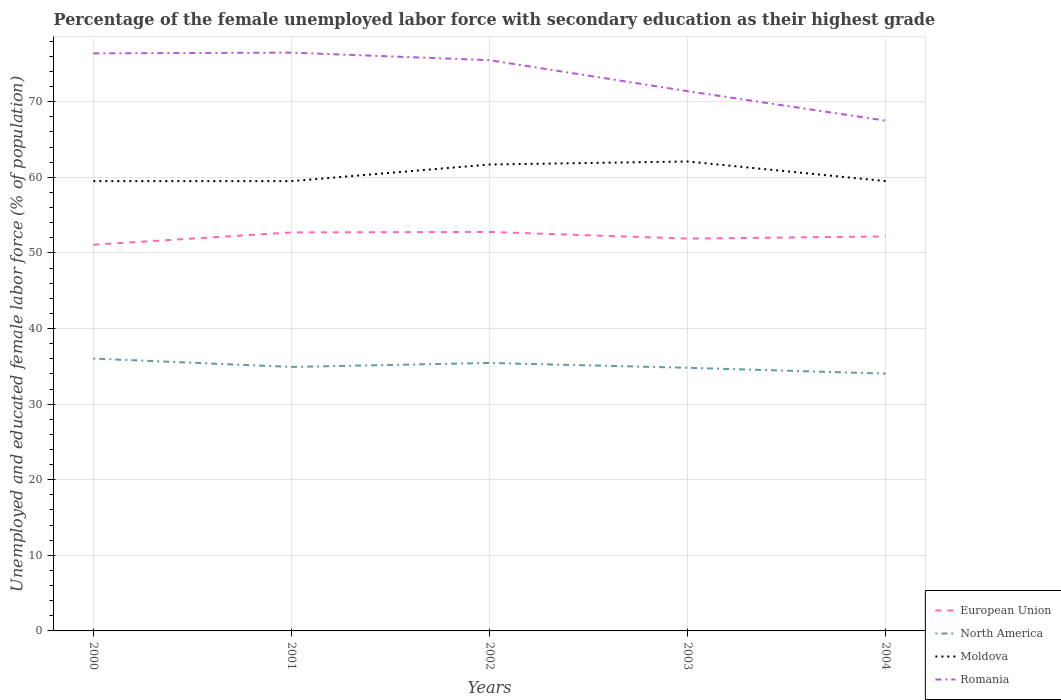Does the line corresponding to North America intersect with the line corresponding to European Union?
Your answer should be compact. No. Across all years, what is the maximum percentage of the unemployed female labor force with secondary education in Romania?
Your answer should be compact. 67.5. In which year was the percentage of the unemployed female labor force with secondary education in Moldova maximum?
Offer a terse response. 2000. What is the total percentage of the unemployed female labor force with secondary education in Romania in the graph?
Your answer should be compact. 5. What is the difference between the highest and the lowest percentage of the unemployed female labor force with secondary education in Moldova?
Offer a very short reply. 2. Does the graph contain any zero values?
Ensure brevity in your answer.  No. Does the graph contain grids?
Make the answer very short. Yes. How many legend labels are there?
Give a very brief answer. 4. How are the legend labels stacked?
Make the answer very short. Vertical. What is the title of the graph?
Offer a terse response. Percentage of the female unemployed labor force with secondary education as their highest grade. What is the label or title of the Y-axis?
Ensure brevity in your answer.  Unemployed and educated female labor force (% of population). What is the Unemployed and educated female labor force (% of population) of European Union in 2000?
Give a very brief answer. 51.09. What is the Unemployed and educated female labor force (% of population) of North America in 2000?
Offer a terse response. 36.03. What is the Unemployed and educated female labor force (% of population) in Moldova in 2000?
Your answer should be compact. 59.5. What is the Unemployed and educated female labor force (% of population) in Romania in 2000?
Your response must be concise. 76.4. What is the Unemployed and educated female labor force (% of population) in European Union in 2001?
Your response must be concise. 52.72. What is the Unemployed and educated female labor force (% of population) in North America in 2001?
Provide a short and direct response. 34.92. What is the Unemployed and educated female labor force (% of population) of Moldova in 2001?
Your answer should be very brief. 59.5. What is the Unemployed and educated female labor force (% of population) in Romania in 2001?
Your answer should be very brief. 76.5. What is the Unemployed and educated female labor force (% of population) in European Union in 2002?
Provide a short and direct response. 52.78. What is the Unemployed and educated female labor force (% of population) of North America in 2002?
Give a very brief answer. 35.45. What is the Unemployed and educated female labor force (% of population) of Moldova in 2002?
Make the answer very short. 61.7. What is the Unemployed and educated female labor force (% of population) of Romania in 2002?
Offer a very short reply. 75.5. What is the Unemployed and educated female labor force (% of population) in European Union in 2003?
Provide a short and direct response. 51.9. What is the Unemployed and educated female labor force (% of population) in North America in 2003?
Keep it short and to the point. 34.81. What is the Unemployed and educated female labor force (% of population) of Moldova in 2003?
Make the answer very short. 62.1. What is the Unemployed and educated female labor force (% of population) of Romania in 2003?
Give a very brief answer. 71.4. What is the Unemployed and educated female labor force (% of population) in European Union in 2004?
Give a very brief answer. 52.19. What is the Unemployed and educated female labor force (% of population) in North America in 2004?
Ensure brevity in your answer.  34.04. What is the Unemployed and educated female labor force (% of population) of Moldova in 2004?
Provide a succinct answer. 59.5. What is the Unemployed and educated female labor force (% of population) of Romania in 2004?
Keep it short and to the point. 67.5. Across all years, what is the maximum Unemployed and educated female labor force (% of population) in European Union?
Give a very brief answer. 52.78. Across all years, what is the maximum Unemployed and educated female labor force (% of population) of North America?
Keep it short and to the point. 36.03. Across all years, what is the maximum Unemployed and educated female labor force (% of population) of Moldova?
Provide a succinct answer. 62.1. Across all years, what is the maximum Unemployed and educated female labor force (% of population) of Romania?
Give a very brief answer. 76.5. Across all years, what is the minimum Unemployed and educated female labor force (% of population) in European Union?
Your answer should be compact. 51.09. Across all years, what is the minimum Unemployed and educated female labor force (% of population) of North America?
Give a very brief answer. 34.04. Across all years, what is the minimum Unemployed and educated female labor force (% of population) of Moldova?
Give a very brief answer. 59.5. Across all years, what is the minimum Unemployed and educated female labor force (% of population) in Romania?
Offer a terse response. 67.5. What is the total Unemployed and educated female labor force (% of population) of European Union in the graph?
Your answer should be compact. 260.67. What is the total Unemployed and educated female labor force (% of population) of North America in the graph?
Ensure brevity in your answer.  175.25. What is the total Unemployed and educated female labor force (% of population) in Moldova in the graph?
Your response must be concise. 302.3. What is the total Unemployed and educated female labor force (% of population) of Romania in the graph?
Offer a very short reply. 367.3. What is the difference between the Unemployed and educated female labor force (% of population) of European Union in 2000 and that in 2001?
Provide a short and direct response. -1.62. What is the difference between the Unemployed and educated female labor force (% of population) of North America in 2000 and that in 2001?
Ensure brevity in your answer.  1.11. What is the difference between the Unemployed and educated female labor force (% of population) in Moldova in 2000 and that in 2001?
Provide a short and direct response. 0. What is the difference between the Unemployed and educated female labor force (% of population) in European Union in 2000 and that in 2002?
Your answer should be very brief. -1.69. What is the difference between the Unemployed and educated female labor force (% of population) of North America in 2000 and that in 2002?
Keep it short and to the point. 0.58. What is the difference between the Unemployed and educated female labor force (% of population) of Romania in 2000 and that in 2002?
Provide a succinct answer. 0.9. What is the difference between the Unemployed and educated female labor force (% of population) of European Union in 2000 and that in 2003?
Provide a short and direct response. -0.81. What is the difference between the Unemployed and educated female labor force (% of population) in North America in 2000 and that in 2003?
Provide a succinct answer. 1.22. What is the difference between the Unemployed and educated female labor force (% of population) in European Union in 2000 and that in 2004?
Make the answer very short. -1.1. What is the difference between the Unemployed and educated female labor force (% of population) in North America in 2000 and that in 2004?
Make the answer very short. 1.99. What is the difference between the Unemployed and educated female labor force (% of population) in Moldova in 2000 and that in 2004?
Keep it short and to the point. 0. What is the difference between the Unemployed and educated female labor force (% of population) in Romania in 2000 and that in 2004?
Make the answer very short. 8.9. What is the difference between the Unemployed and educated female labor force (% of population) in European Union in 2001 and that in 2002?
Make the answer very short. -0.06. What is the difference between the Unemployed and educated female labor force (% of population) in North America in 2001 and that in 2002?
Give a very brief answer. -0.53. What is the difference between the Unemployed and educated female labor force (% of population) in Moldova in 2001 and that in 2002?
Make the answer very short. -2.2. What is the difference between the Unemployed and educated female labor force (% of population) of Romania in 2001 and that in 2002?
Ensure brevity in your answer.  1. What is the difference between the Unemployed and educated female labor force (% of population) in European Union in 2001 and that in 2003?
Provide a short and direct response. 0.82. What is the difference between the Unemployed and educated female labor force (% of population) in North America in 2001 and that in 2003?
Provide a short and direct response. 0.11. What is the difference between the Unemployed and educated female labor force (% of population) of Romania in 2001 and that in 2003?
Ensure brevity in your answer.  5.1. What is the difference between the Unemployed and educated female labor force (% of population) of European Union in 2001 and that in 2004?
Provide a short and direct response. 0.53. What is the difference between the Unemployed and educated female labor force (% of population) in North America in 2001 and that in 2004?
Provide a short and direct response. 0.88. What is the difference between the Unemployed and educated female labor force (% of population) in Moldova in 2001 and that in 2004?
Keep it short and to the point. 0. What is the difference between the Unemployed and educated female labor force (% of population) in European Union in 2002 and that in 2003?
Your answer should be compact. 0.88. What is the difference between the Unemployed and educated female labor force (% of population) of North America in 2002 and that in 2003?
Your answer should be very brief. 0.64. What is the difference between the Unemployed and educated female labor force (% of population) in Romania in 2002 and that in 2003?
Ensure brevity in your answer.  4.1. What is the difference between the Unemployed and educated female labor force (% of population) in European Union in 2002 and that in 2004?
Make the answer very short. 0.59. What is the difference between the Unemployed and educated female labor force (% of population) of North America in 2002 and that in 2004?
Your answer should be very brief. 1.41. What is the difference between the Unemployed and educated female labor force (% of population) in Romania in 2002 and that in 2004?
Your answer should be compact. 8. What is the difference between the Unemployed and educated female labor force (% of population) of European Union in 2003 and that in 2004?
Your answer should be very brief. -0.29. What is the difference between the Unemployed and educated female labor force (% of population) in North America in 2003 and that in 2004?
Provide a short and direct response. 0.77. What is the difference between the Unemployed and educated female labor force (% of population) in Moldova in 2003 and that in 2004?
Your response must be concise. 2.6. What is the difference between the Unemployed and educated female labor force (% of population) of European Union in 2000 and the Unemployed and educated female labor force (% of population) of North America in 2001?
Your answer should be very brief. 16.17. What is the difference between the Unemployed and educated female labor force (% of population) of European Union in 2000 and the Unemployed and educated female labor force (% of population) of Moldova in 2001?
Keep it short and to the point. -8.41. What is the difference between the Unemployed and educated female labor force (% of population) of European Union in 2000 and the Unemployed and educated female labor force (% of population) of Romania in 2001?
Make the answer very short. -25.41. What is the difference between the Unemployed and educated female labor force (% of population) of North America in 2000 and the Unemployed and educated female labor force (% of population) of Moldova in 2001?
Provide a succinct answer. -23.47. What is the difference between the Unemployed and educated female labor force (% of population) of North America in 2000 and the Unemployed and educated female labor force (% of population) of Romania in 2001?
Your answer should be very brief. -40.47. What is the difference between the Unemployed and educated female labor force (% of population) of Moldova in 2000 and the Unemployed and educated female labor force (% of population) of Romania in 2001?
Your response must be concise. -17. What is the difference between the Unemployed and educated female labor force (% of population) of European Union in 2000 and the Unemployed and educated female labor force (% of population) of North America in 2002?
Offer a terse response. 15.64. What is the difference between the Unemployed and educated female labor force (% of population) in European Union in 2000 and the Unemployed and educated female labor force (% of population) in Moldova in 2002?
Your answer should be compact. -10.61. What is the difference between the Unemployed and educated female labor force (% of population) of European Union in 2000 and the Unemployed and educated female labor force (% of population) of Romania in 2002?
Keep it short and to the point. -24.41. What is the difference between the Unemployed and educated female labor force (% of population) in North America in 2000 and the Unemployed and educated female labor force (% of population) in Moldova in 2002?
Your answer should be very brief. -25.67. What is the difference between the Unemployed and educated female labor force (% of population) of North America in 2000 and the Unemployed and educated female labor force (% of population) of Romania in 2002?
Your answer should be very brief. -39.47. What is the difference between the Unemployed and educated female labor force (% of population) of Moldova in 2000 and the Unemployed and educated female labor force (% of population) of Romania in 2002?
Keep it short and to the point. -16. What is the difference between the Unemployed and educated female labor force (% of population) in European Union in 2000 and the Unemployed and educated female labor force (% of population) in North America in 2003?
Provide a short and direct response. 16.28. What is the difference between the Unemployed and educated female labor force (% of population) in European Union in 2000 and the Unemployed and educated female labor force (% of population) in Moldova in 2003?
Your answer should be very brief. -11.01. What is the difference between the Unemployed and educated female labor force (% of population) in European Union in 2000 and the Unemployed and educated female labor force (% of population) in Romania in 2003?
Your response must be concise. -20.31. What is the difference between the Unemployed and educated female labor force (% of population) in North America in 2000 and the Unemployed and educated female labor force (% of population) in Moldova in 2003?
Your answer should be very brief. -26.07. What is the difference between the Unemployed and educated female labor force (% of population) of North America in 2000 and the Unemployed and educated female labor force (% of population) of Romania in 2003?
Keep it short and to the point. -35.37. What is the difference between the Unemployed and educated female labor force (% of population) in European Union in 2000 and the Unemployed and educated female labor force (% of population) in North America in 2004?
Your response must be concise. 17.05. What is the difference between the Unemployed and educated female labor force (% of population) of European Union in 2000 and the Unemployed and educated female labor force (% of population) of Moldova in 2004?
Keep it short and to the point. -8.41. What is the difference between the Unemployed and educated female labor force (% of population) of European Union in 2000 and the Unemployed and educated female labor force (% of population) of Romania in 2004?
Make the answer very short. -16.41. What is the difference between the Unemployed and educated female labor force (% of population) in North America in 2000 and the Unemployed and educated female labor force (% of population) in Moldova in 2004?
Your answer should be compact. -23.47. What is the difference between the Unemployed and educated female labor force (% of population) of North America in 2000 and the Unemployed and educated female labor force (% of population) of Romania in 2004?
Provide a short and direct response. -31.47. What is the difference between the Unemployed and educated female labor force (% of population) in European Union in 2001 and the Unemployed and educated female labor force (% of population) in North America in 2002?
Your response must be concise. 17.27. What is the difference between the Unemployed and educated female labor force (% of population) in European Union in 2001 and the Unemployed and educated female labor force (% of population) in Moldova in 2002?
Your answer should be compact. -8.98. What is the difference between the Unemployed and educated female labor force (% of population) in European Union in 2001 and the Unemployed and educated female labor force (% of population) in Romania in 2002?
Provide a succinct answer. -22.78. What is the difference between the Unemployed and educated female labor force (% of population) of North America in 2001 and the Unemployed and educated female labor force (% of population) of Moldova in 2002?
Offer a very short reply. -26.78. What is the difference between the Unemployed and educated female labor force (% of population) in North America in 2001 and the Unemployed and educated female labor force (% of population) in Romania in 2002?
Your answer should be very brief. -40.58. What is the difference between the Unemployed and educated female labor force (% of population) of Moldova in 2001 and the Unemployed and educated female labor force (% of population) of Romania in 2002?
Provide a short and direct response. -16. What is the difference between the Unemployed and educated female labor force (% of population) in European Union in 2001 and the Unemployed and educated female labor force (% of population) in North America in 2003?
Offer a terse response. 17.91. What is the difference between the Unemployed and educated female labor force (% of population) in European Union in 2001 and the Unemployed and educated female labor force (% of population) in Moldova in 2003?
Your response must be concise. -9.38. What is the difference between the Unemployed and educated female labor force (% of population) of European Union in 2001 and the Unemployed and educated female labor force (% of population) of Romania in 2003?
Provide a short and direct response. -18.68. What is the difference between the Unemployed and educated female labor force (% of population) of North America in 2001 and the Unemployed and educated female labor force (% of population) of Moldova in 2003?
Offer a terse response. -27.18. What is the difference between the Unemployed and educated female labor force (% of population) in North America in 2001 and the Unemployed and educated female labor force (% of population) in Romania in 2003?
Offer a terse response. -36.48. What is the difference between the Unemployed and educated female labor force (% of population) of European Union in 2001 and the Unemployed and educated female labor force (% of population) of North America in 2004?
Ensure brevity in your answer.  18.68. What is the difference between the Unemployed and educated female labor force (% of population) of European Union in 2001 and the Unemployed and educated female labor force (% of population) of Moldova in 2004?
Your response must be concise. -6.78. What is the difference between the Unemployed and educated female labor force (% of population) in European Union in 2001 and the Unemployed and educated female labor force (% of population) in Romania in 2004?
Your answer should be very brief. -14.78. What is the difference between the Unemployed and educated female labor force (% of population) in North America in 2001 and the Unemployed and educated female labor force (% of population) in Moldova in 2004?
Provide a short and direct response. -24.58. What is the difference between the Unemployed and educated female labor force (% of population) in North America in 2001 and the Unemployed and educated female labor force (% of population) in Romania in 2004?
Give a very brief answer. -32.58. What is the difference between the Unemployed and educated female labor force (% of population) of European Union in 2002 and the Unemployed and educated female labor force (% of population) of North America in 2003?
Keep it short and to the point. 17.97. What is the difference between the Unemployed and educated female labor force (% of population) in European Union in 2002 and the Unemployed and educated female labor force (% of population) in Moldova in 2003?
Make the answer very short. -9.32. What is the difference between the Unemployed and educated female labor force (% of population) in European Union in 2002 and the Unemployed and educated female labor force (% of population) in Romania in 2003?
Ensure brevity in your answer.  -18.62. What is the difference between the Unemployed and educated female labor force (% of population) in North America in 2002 and the Unemployed and educated female labor force (% of population) in Moldova in 2003?
Provide a succinct answer. -26.65. What is the difference between the Unemployed and educated female labor force (% of population) in North America in 2002 and the Unemployed and educated female labor force (% of population) in Romania in 2003?
Your response must be concise. -35.95. What is the difference between the Unemployed and educated female labor force (% of population) of Moldova in 2002 and the Unemployed and educated female labor force (% of population) of Romania in 2003?
Provide a succinct answer. -9.7. What is the difference between the Unemployed and educated female labor force (% of population) of European Union in 2002 and the Unemployed and educated female labor force (% of population) of North America in 2004?
Offer a terse response. 18.74. What is the difference between the Unemployed and educated female labor force (% of population) in European Union in 2002 and the Unemployed and educated female labor force (% of population) in Moldova in 2004?
Offer a very short reply. -6.72. What is the difference between the Unemployed and educated female labor force (% of population) of European Union in 2002 and the Unemployed and educated female labor force (% of population) of Romania in 2004?
Provide a short and direct response. -14.72. What is the difference between the Unemployed and educated female labor force (% of population) in North America in 2002 and the Unemployed and educated female labor force (% of population) in Moldova in 2004?
Your response must be concise. -24.05. What is the difference between the Unemployed and educated female labor force (% of population) of North America in 2002 and the Unemployed and educated female labor force (% of population) of Romania in 2004?
Your answer should be compact. -32.05. What is the difference between the Unemployed and educated female labor force (% of population) in European Union in 2003 and the Unemployed and educated female labor force (% of population) in North America in 2004?
Your response must be concise. 17.86. What is the difference between the Unemployed and educated female labor force (% of population) in European Union in 2003 and the Unemployed and educated female labor force (% of population) in Moldova in 2004?
Offer a very short reply. -7.6. What is the difference between the Unemployed and educated female labor force (% of population) in European Union in 2003 and the Unemployed and educated female labor force (% of population) in Romania in 2004?
Provide a short and direct response. -15.6. What is the difference between the Unemployed and educated female labor force (% of population) in North America in 2003 and the Unemployed and educated female labor force (% of population) in Moldova in 2004?
Offer a very short reply. -24.69. What is the difference between the Unemployed and educated female labor force (% of population) in North America in 2003 and the Unemployed and educated female labor force (% of population) in Romania in 2004?
Your response must be concise. -32.69. What is the difference between the Unemployed and educated female labor force (% of population) of Moldova in 2003 and the Unemployed and educated female labor force (% of population) of Romania in 2004?
Keep it short and to the point. -5.4. What is the average Unemployed and educated female labor force (% of population) in European Union per year?
Your answer should be compact. 52.13. What is the average Unemployed and educated female labor force (% of population) in North America per year?
Provide a short and direct response. 35.05. What is the average Unemployed and educated female labor force (% of population) of Moldova per year?
Offer a terse response. 60.46. What is the average Unemployed and educated female labor force (% of population) of Romania per year?
Make the answer very short. 73.46. In the year 2000, what is the difference between the Unemployed and educated female labor force (% of population) in European Union and Unemployed and educated female labor force (% of population) in North America?
Make the answer very short. 15.06. In the year 2000, what is the difference between the Unemployed and educated female labor force (% of population) of European Union and Unemployed and educated female labor force (% of population) of Moldova?
Your response must be concise. -8.41. In the year 2000, what is the difference between the Unemployed and educated female labor force (% of population) in European Union and Unemployed and educated female labor force (% of population) in Romania?
Your answer should be very brief. -25.31. In the year 2000, what is the difference between the Unemployed and educated female labor force (% of population) in North America and Unemployed and educated female labor force (% of population) in Moldova?
Give a very brief answer. -23.47. In the year 2000, what is the difference between the Unemployed and educated female labor force (% of population) of North America and Unemployed and educated female labor force (% of population) of Romania?
Ensure brevity in your answer.  -40.37. In the year 2000, what is the difference between the Unemployed and educated female labor force (% of population) in Moldova and Unemployed and educated female labor force (% of population) in Romania?
Provide a succinct answer. -16.9. In the year 2001, what is the difference between the Unemployed and educated female labor force (% of population) of European Union and Unemployed and educated female labor force (% of population) of North America?
Offer a very short reply. 17.79. In the year 2001, what is the difference between the Unemployed and educated female labor force (% of population) in European Union and Unemployed and educated female labor force (% of population) in Moldova?
Keep it short and to the point. -6.78. In the year 2001, what is the difference between the Unemployed and educated female labor force (% of population) of European Union and Unemployed and educated female labor force (% of population) of Romania?
Give a very brief answer. -23.78. In the year 2001, what is the difference between the Unemployed and educated female labor force (% of population) in North America and Unemployed and educated female labor force (% of population) in Moldova?
Your answer should be compact. -24.58. In the year 2001, what is the difference between the Unemployed and educated female labor force (% of population) in North America and Unemployed and educated female labor force (% of population) in Romania?
Your answer should be very brief. -41.58. In the year 2001, what is the difference between the Unemployed and educated female labor force (% of population) in Moldova and Unemployed and educated female labor force (% of population) in Romania?
Keep it short and to the point. -17. In the year 2002, what is the difference between the Unemployed and educated female labor force (% of population) in European Union and Unemployed and educated female labor force (% of population) in North America?
Your response must be concise. 17.33. In the year 2002, what is the difference between the Unemployed and educated female labor force (% of population) in European Union and Unemployed and educated female labor force (% of population) in Moldova?
Provide a short and direct response. -8.92. In the year 2002, what is the difference between the Unemployed and educated female labor force (% of population) in European Union and Unemployed and educated female labor force (% of population) in Romania?
Your response must be concise. -22.72. In the year 2002, what is the difference between the Unemployed and educated female labor force (% of population) of North America and Unemployed and educated female labor force (% of population) of Moldova?
Ensure brevity in your answer.  -26.25. In the year 2002, what is the difference between the Unemployed and educated female labor force (% of population) of North America and Unemployed and educated female labor force (% of population) of Romania?
Offer a very short reply. -40.05. In the year 2003, what is the difference between the Unemployed and educated female labor force (% of population) in European Union and Unemployed and educated female labor force (% of population) in North America?
Offer a terse response. 17.09. In the year 2003, what is the difference between the Unemployed and educated female labor force (% of population) in European Union and Unemployed and educated female labor force (% of population) in Moldova?
Your answer should be compact. -10.2. In the year 2003, what is the difference between the Unemployed and educated female labor force (% of population) in European Union and Unemployed and educated female labor force (% of population) in Romania?
Your response must be concise. -19.5. In the year 2003, what is the difference between the Unemployed and educated female labor force (% of population) of North America and Unemployed and educated female labor force (% of population) of Moldova?
Your answer should be compact. -27.29. In the year 2003, what is the difference between the Unemployed and educated female labor force (% of population) in North America and Unemployed and educated female labor force (% of population) in Romania?
Your response must be concise. -36.59. In the year 2004, what is the difference between the Unemployed and educated female labor force (% of population) of European Union and Unemployed and educated female labor force (% of population) of North America?
Provide a short and direct response. 18.15. In the year 2004, what is the difference between the Unemployed and educated female labor force (% of population) in European Union and Unemployed and educated female labor force (% of population) in Moldova?
Provide a succinct answer. -7.31. In the year 2004, what is the difference between the Unemployed and educated female labor force (% of population) of European Union and Unemployed and educated female labor force (% of population) of Romania?
Offer a terse response. -15.31. In the year 2004, what is the difference between the Unemployed and educated female labor force (% of population) of North America and Unemployed and educated female labor force (% of population) of Moldova?
Your answer should be compact. -25.46. In the year 2004, what is the difference between the Unemployed and educated female labor force (% of population) of North America and Unemployed and educated female labor force (% of population) of Romania?
Your answer should be very brief. -33.46. In the year 2004, what is the difference between the Unemployed and educated female labor force (% of population) in Moldova and Unemployed and educated female labor force (% of population) in Romania?
Offer a terse response. -8. What is the ratio of the Unemployed and educated female labor force (% of population) of European Union in 2000 to that in 2001?
Provide a succinct answer. 0.97. What is the ratio of the Unemployed and educated female labor force (% of population) in North America in 2000 to that in 2001?
Make the answer very short. 1.03. What is the ratio of the Unemployed and educated female labor force (% of population) of Moldova in 2000 to that in 2001?
Offer a terse response. 1. What is the ratio of the Unemployed and educated female labor force (% of population) of Romania in 2000 to that in 2001?
Your answer should be compact. 1. What is the ratio of the Unemployed and educated female labor force (% of population) of North America in 2000 to that in 2002?
Provide a short and direct response. 1.02. What is the ratio of the Unemployed and educated female labor force (% of population) of Romania in 2000 to that in 2002?
Give a very brief answer. 1.01. What is the ratio of the Unemployed and educated female labor force (% of population) of European Union in 2000 to that in 2003?
Ensure brevity in your answer.  0.98. What is the ratio of the Unemployed and educated female labor force (% of population) in North America in 2000 to that in 2003?
Your response must be concise. 1.04. What is the ratio of the Unemployed and educated female labor force (% of population) in Moldova in 2000 to that in 2003?
Your response must be concise. 0.96. What is the ratio of the Unemployed and educated female labor force (% of population) in Romania in 2000 to that in 2003?
Offer a very short reply. 1.07. What is the ratio of the Unemployed and educated female labor force (% of population) in North America in 2000 to that in 2004?
Offer a terse response. 1.06. What is the ratio of the Unemployed and educated female labor force (% of population) of Romania in 2000 to that in 2004?
Offer a terse response. 1.13. What is the ratio of the Unemployed and educated female labor force (% of population) in European Union in 2001 to that in 2002?
Your response must be concise. 1. What is the ratio of the Unemployed and educated female labor force (% of population) of North America in 2001 to that in 2002?
Provide a short and direct response. 0.99. What is the ratio of the Unemployed and educated female labor force (% of population) in Moldova in 2001 to that in 2002?
Give a very brief answer. 0.96. What is the ratio of the Unemployed and educated female labor force (% of population) of Romania in 2001 to that in 2002?
Your answer should be compact. 1.01. What is the ratio of the Unemployed and educated female labor force (% of population) of European Union in 2001 to that in 2003?
Make the answer very short. 1.02. What is the ratio of the Unemployed and educated female labor force (% of population) in North America in 2001 to that in 2003?
Offer a very short reply. 1. What is the ratio of the Unemployed and educated female labor force (% of population) in Moldova in 2001 to that in 2003?
Ensure brevity in your answer.  0.96. What is the ratio of the Unemployed and educated female labor force (% of population) in Romania in 2001 to that in 2003?
Ensure brevity in your answer.  1.07. What is the ratio of the Unemployed and educated female labor force (% of population) of North America in 2001 to that in 2004?
Give a very brief answer. 1.03. What is the ratio of the Unemployed and educated female labor force (% of population) of Romania in 2001 to that in 2004?
Offer a terse response. 1.13. What is the ratio of the Unemployed and educated female labor force (% of population) in European Union in 2002 to that in 2003?
Offer a very short reply. 1.02. What is the ratio of the Unemployed and educated female labor force (% of population) of North America in 2002 to that in 2003?
Provide a succinct answer. 1.02. What is the ratio of the Unemployed and educated female labor force (% of population) in Moldova in 2002 to that in 2003?
Ensure brevity in your answer.  0.99. What is the ratio of the Unemployed and educated female labor force (% of population) in Romania in 2002 to that in 2003?
Your answer should be compact. 1.06. What is the ratio of the Unemployed and educated female labor force (% of population) in European Union in 2002 to that in 2004?
Offer a very short reply. 1.01. What is the ratio of the Unemployed and educated female labor force (% of population) of North America in 2002 to that in 2004?
Your answer should be compact. 1.04. What is the ratio of the Unemployed and educated female labor force (% of population) of Romania in 2002 to that in 2004?
Ensure brevity in your answer.  1.12. What is the ratio of the Unemployed and educated female labor force (% of population) of North America in 2003 to that in 2004?
Provide a succinct answer. 1.02. What is the ratio of the Unemployed and educated female labor force (% of population) of Moldova in 2003 to that in 2004?
Keep it short and to the point. 1.04. What is the ratio of the Unemployed and educated female labor force (% of population) of Romania in 2003 to that in 2004?
Your answer should be very brief. 1.06. What is the difference between the highest and the second highest Unemployed and educated female labor force (% of population) in European Union?
Your response must be concise. 0.06. What is the difference between the highest and the second highest Unemployed and educated female labor force (% of population) in North America?
Your response must be concise. 0.58. What is the difference between the highest and the second highest Unemployed and educated female labor force (% of population) of Romania?
Offer a very short reply. 0.1. What is the difference between the highest and the lowest Unemployed and educated female labor force (% of population) in European Union?
Provide a succinct answer. 1.69. What is the difference between the highest and the lowest Unemployed and educated female labor force (% of population) of North America?
Make the answer very short. 1.99. What is the difference between the highest and the lowest Unemployed and educated female labor force (% of population) of Moldova?
Keep it short and to the point. 2.6. 